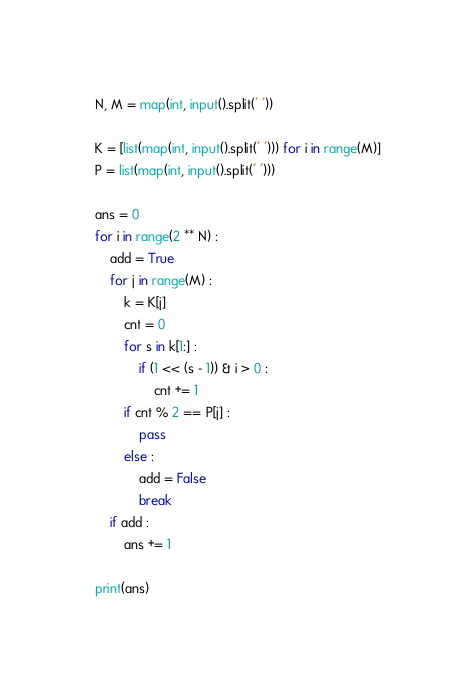<code> <loc_0><loc_0><loc_500><loc_500><_Python_>N, M = map(int, input().split(' '))

K = [list(map(int, input().split(' '))) for i in range(M)]
P = list(map(int, input().split(' ')))

ans = 0
for i in range(2 ** N) :
    add = True
    for j in range(M) :
        k = K[j]
        cnt = 0
        for s in k[1:] :
            if (1 << (s - 1)) & i > 0 :
                cnt += 1
        if cnt % 2 == P[j] :
            pass
        else :
            add = False
            break
    if add :
        ans += 1

print(ans)
</code> 